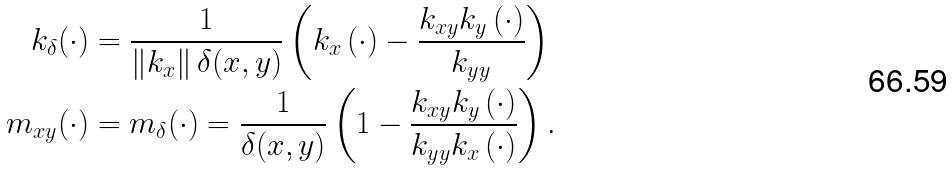<formula> <loc_0><loc_0><loc_500><loc_500>k _ { \delta } ( \cdot ) & = \frac { 1 } { \left \| k _ { x } \right \| \delta ( x , y ) } \left ( k _ { x } \left ( \cdot \right ) - \frac { k _ { x y } k _ { y } \left ( \cdot \right ) } { k _ { y y } } \right ) \\ m _ { x y } ( \cdot ) & = m _ { \delta } ( \cdot ) = \frac { 1 } { \delta ( x , y ) } \left ( 1 - \frac { k _ { x y } k _ { y } \left ( \cdot \right ) } { k _ { y y } k _ { x } \left ( \cdot \right ) } \right ) .</formula> 